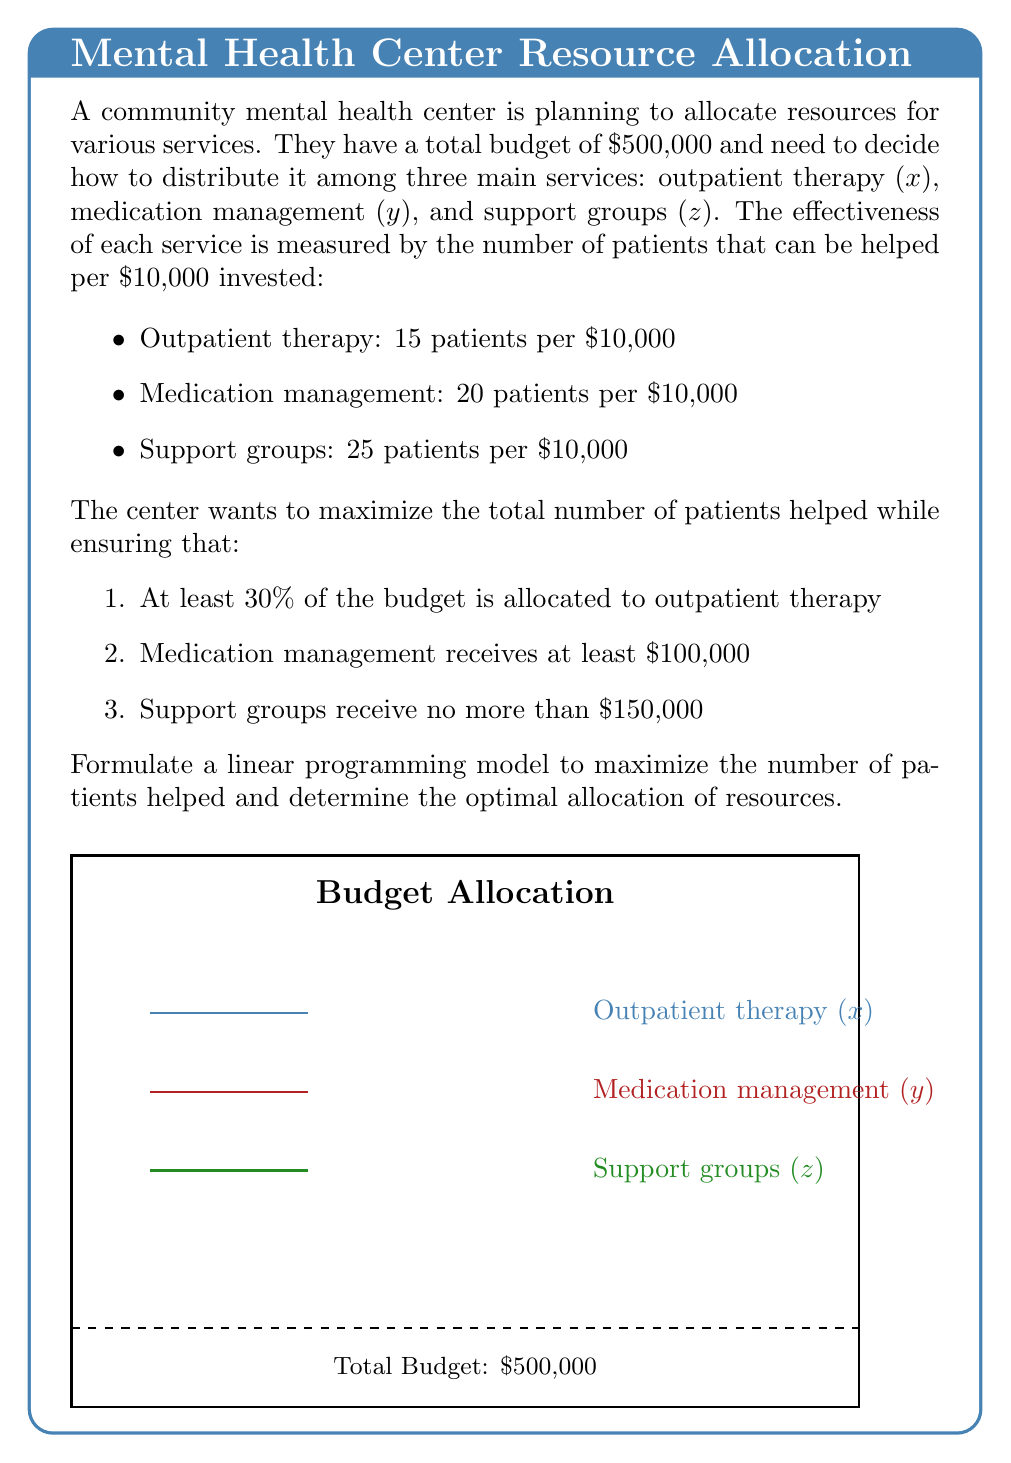Can you solve this math problem? Let's formulate the linear programming model step by step:

1) Define decision variables:
   $x$ = amount allocated to outpatient therapy
   $y$ = amount allocated to medication management
   $z$ = amount allocated to support groups

2) Objective function:
   Maximize the total number of patients helped
   $$\text{Max } \frac{15x}{10000} + \frac{20y}{10000} + \frac{25z}{10000}$$
   Simplifying: $$\text{Max } 0.0015x + 0.002y + 0.0025z$$

3) Constraints:
   a) Total budget constraint:
      $$x + y + z \leq 500000$$
   
   b) At least 30% of the budget for outpatient therapy:
      $$x \geq 0.3 * 500000 = 150000$$
   
   c) Medication management receives at least $100,000:
      $$y \geq 100000$$
   
   d) Support groups receive no more than $150,000:
      $$z \leq 150000$$
   
   e) Non-negativity constraints:
      $$x, y, z \geq 0$$

4) Complete linear programming model:

   Maximize: $0.0015x + 0.002y + 0.0025z$
   
   Subject to:
   $$x + y + z \leq 500000$$
   $$x \geq 150000$$
   $$y \geq 100000$$
   $$z \leq 150000$$
   $$x, y, z \geq 0$$

This model can be solved using linear programming techniques such as the simplex method or interior point methods.
Answer: Max: $0.0015x + 0.002y + 0.0025z$
s.t. $x + y + z \leq 500000$, $x \geq 150000$, $y \geq 100000$, $z \leq 150000$, $x, y, z \geq 0$ 